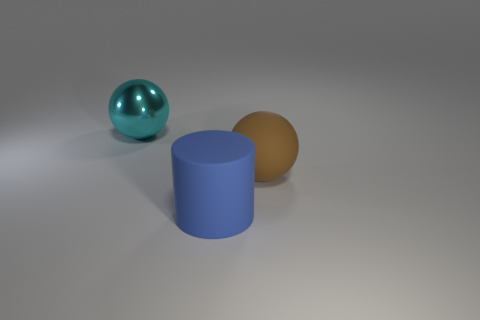Are there any other things that have the same material as the brown thing?
Keep it short and to the point. Yes. Is the brown object made of the same material as the large cyan ball?
Offer a very short reply. No. There is a large thing that is in front of the sphere that is in front of the thing that is left of the big blue matte cylinder; what shape is it?
Your answer should be compact. Cylinder. Are there fewer large brown spheres that are in front of the large rubber cylinder than brown spheres that are right of the large cyan object?
Provide a short and direct response. Yes. What shape is the big matte thing in front of the sphere on the right side of the cyan sphere?
Ensure brevity in your answer.  Cylinder. Is there anything else that has the same color as the cylinder?
Offer a terse response. No. How many brown objects are either big cubes or big matte things?
Provide a short and direct response. 1. Is the number of big metallic objects that are left of the large brown ball less than the number of big green metallic spheres?
Provide a short and direct response. No. There is a large ball on the right side of the cyan sphere; what number of objects are in front of it?
Give a very brief answer. 1. What number of other objects are the same size as the blue matte cylinder?
Ensure brevity in your answer.  2. 